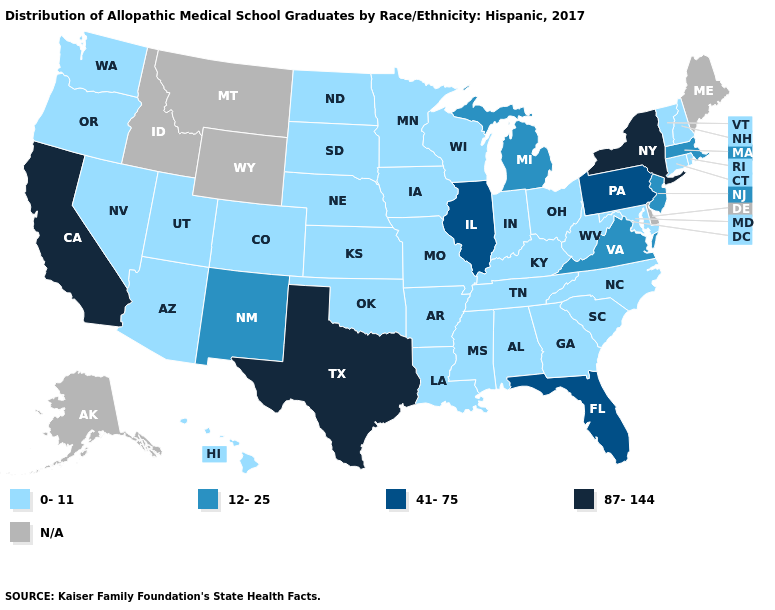What is the value of Alabama?
Short answer required. 0-11. What is the value of Maryland?
Keep it brief. 0-11. Which states have the lowest value in the South?
Answer briefly. Alabama, Arkansas, Georgia, Kentucky, Louisiana, Maryland, Mississippi, North Carolina, Oklahoma, South Carolina, Tennessee, West Virginia. Which states hav the highest value in the West?
Be succinct. California. Does North Carolina have the lowest value in the USA?
Answer briefly. Yes. Among the states that border Oregon , does California have the lowest value?
Answer briefly. No. Name the states that have a value in the range 12-25?
Keep it brief. Massachusetts, Michigan, New Jersey, New Mexico, Virginia. What is the value of Delaware?
Give a very brief answer. N/A. What is the value of Iowa?
Concise answer only. 0-11. Which states have the lowest value in the MidWest?
Concise answer only. Indiana, Iowa, Kansas, Minnesota, Missouri, Nebraska, North Dakota, Ohio, South Dakota, Wisconsin. Name the states that have a value in the range 41-75?
Concise answer only. Florida, Illinois, Pennsylvania. How many symbols are there in the legend?
Give a very brief answer. 5. 